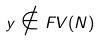<formula> <loc_0><loc_0><loc_500><loc_500>y \notin F V ( N )</formula> 